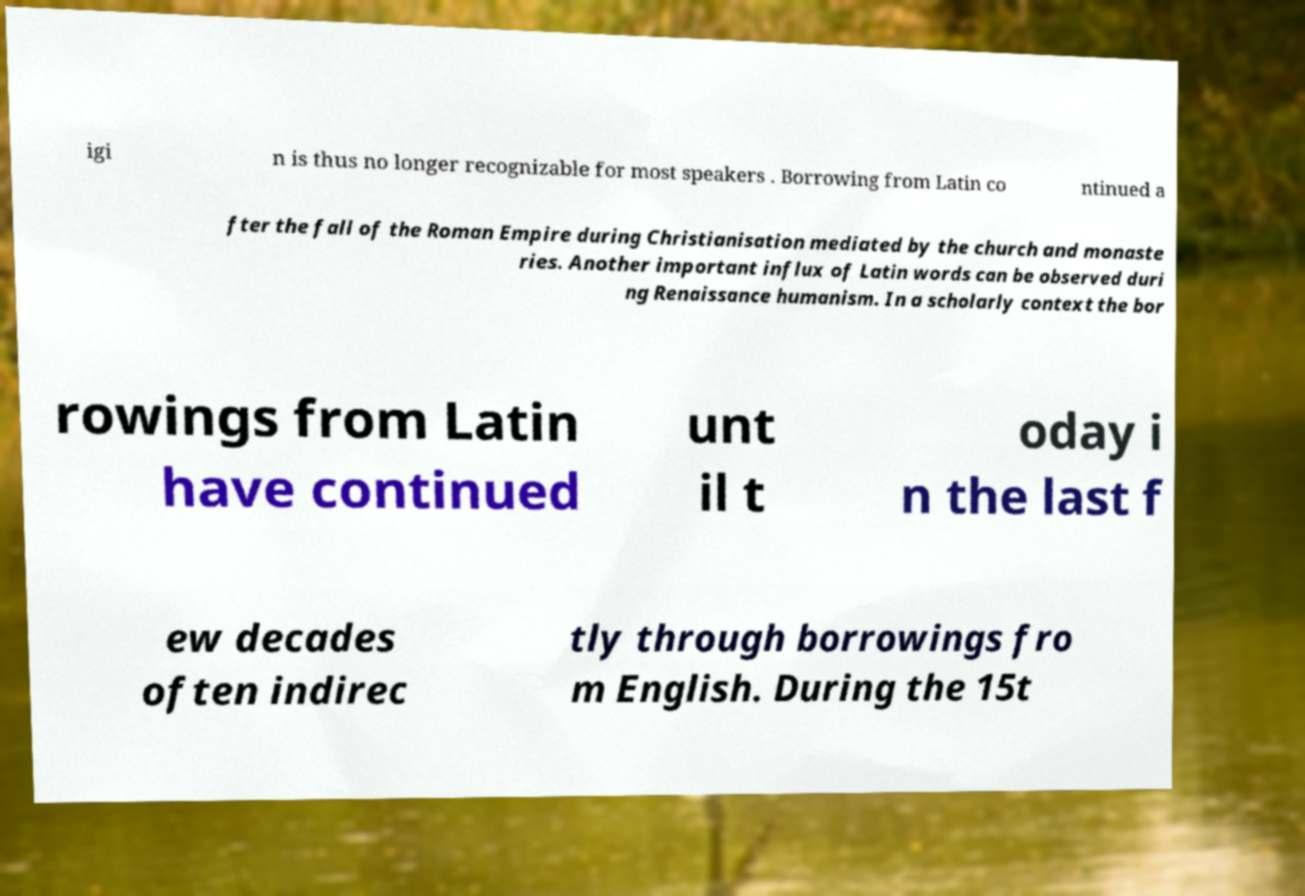Can you read and provide the text displayed in the image?This photo seems to have some interesting text. Can you extract and type it out for me? igi n is thus no longer recognizable for most speakers . Borrowing from Latin co ntinued a fter the fall of the Roman Empire during Christianisation mediated by the church and monaste ries. Another important influx of Latin words can be observed duri ng Renaissance humanism. In a scholarly context the bor rowings from Latin have continued unt il t oday i n the last f ew decades often indirec tly through borrowings fro m English. During the 15t 